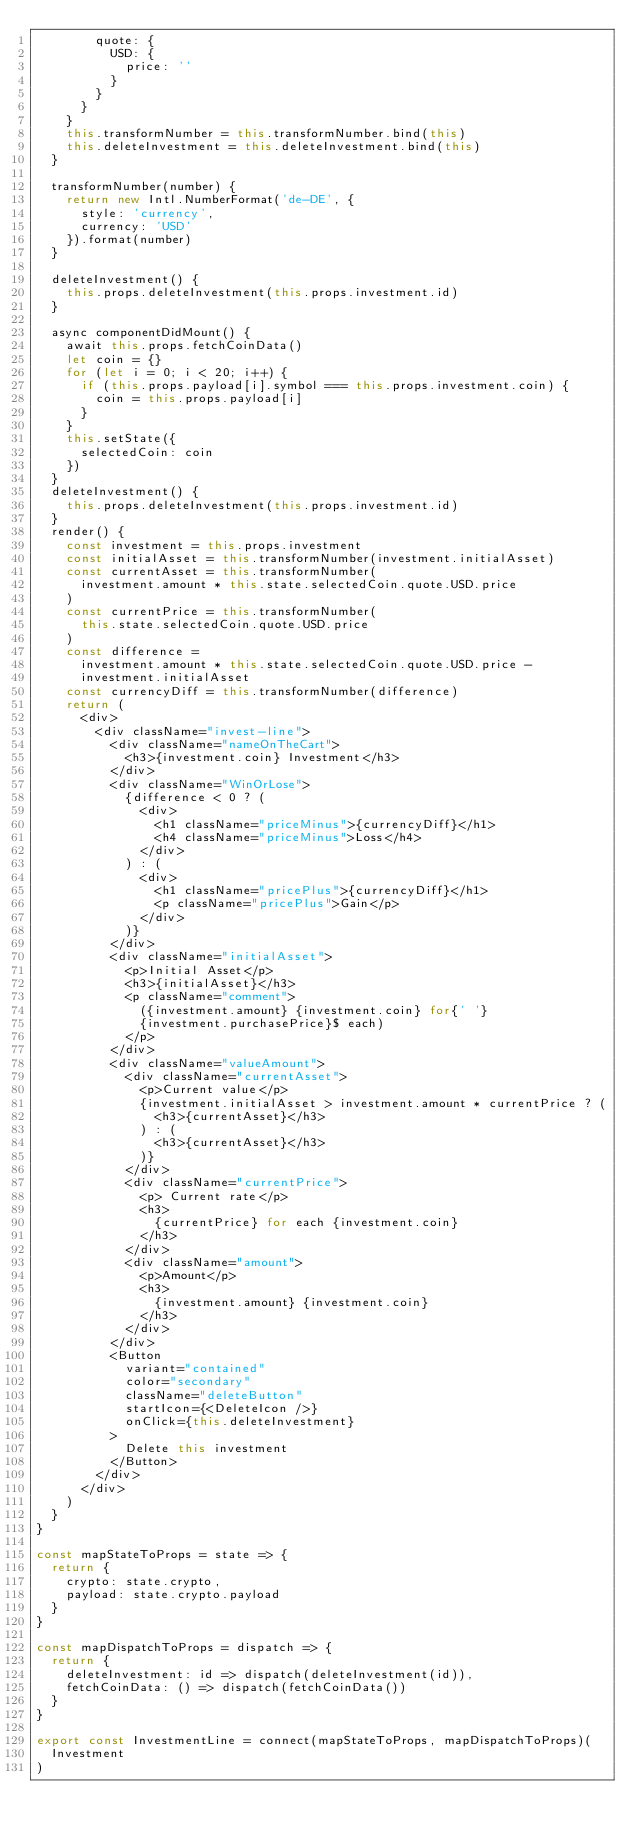Convert code to text. <code><loc_0><loc_0><loc_500><loc_500><_JavaScript_>        quote: {
          USD: {
            price: ''
          }
        }
      }
    }
    this.transformNumber = this.transformNumber.bind(this)
    this.deleteInvestment = this.deleteInvestment.bind(this)
  }

  transformNumber(number) {
    return new Intl.NumberFormat('de-DE', {
      style: 'currency',
      currency: 'USD'
    }).format(number)
  }

  deleteInvestment() {
    this.props.deleteInvestment(this.props.investment.id)
  }

  async componentDidMount() {
    await this.props.fetchCoinData()
    let coin = {}
    for (let i = 0; i < 20; i++) {
      if (this.props.payload[i].symbol === this.props.investment.coin) {
        coin = this.props.payload[i]
      }
    }
    this.setState({
      selectedCoin: coin
    })
  }
  deleteInvestment() {
    this.props.deleteInvestment(this.props.investment.id)
  }
  render() {
    const investment = this.props.investment
    const initialAsset = this.transformNumber(investment.initialAsset)
    const currentAsset = this.transformNumber(
      investment.amount * this.state.selectedCoin.quote.USD.price
    )
    const currentPrice = this.transformNumber(
      this.state.selectedCoin.quote.USD.price
    )
    const difference =
      investment.amount * this.state.selectedCoin.quote.USD.price -
      investment.initialAsset
    const currencyDiff = this.transformNumber(difference)
    return (
      <div>
        <div className="invest-line">
          <div className="nameOnTheCart">
            <h3>{investment.coin} Investment</h3>
          </div>
          <div className="WinOrLose">
            {difference < 0 ? (
              <div>
                <h1 className="priceMinus">{currencyDiff}</h1>
                <h4 className="priceMinus">Loss</h4>
              </div>
            ) : (
              <div>
                <h1 className="pricePlus">{currencyDiff}</h1>
                <p className="pricePlus">Gain</p>
              </div>
            )}
          </div>
          <div className="initialAsset">
            <p>Initial Asset</p>
            <h3>{initialAsset}</h3>
            <p className="comment">
              ({investment.amount} {investment.coin} for{' '}
              {investment.purchasePrice}$ each)
            </p>
          </div>
          <div className="valueAmount">
            <div className="currentAsset">
              <p>Current value</p>
              {investment.initialAsset > investment.amount * currentPrice ? (
                <h3>{currentAsset}</h3>
              ) : (
                <h3>{currentAsset}</h3>
              )}
            </div>
            <div className="currentPrice">
              <p> Current rate</p>
              <h3>
                {currentPrice} for each {investment.coin}
              </h3>
            </div>
            <div className="amount">
              <p>Amount</p>
              <h3>
                {investment.amount} {investment.coin}
              </h3>
            </div>
          </div>
          <Button
            variant="contained"
            color="secondary"
            className="deleteButton"
            startIcon={<DeleteIcon />}
            onClick={this.deleteInvestment}
          >
            Delete this investment
          </Button>
        </div>
      </div>
    )
  }
}

const mapStateToProps = state => {
  return {
    crypto: state.crypto,
    payload: state.crypto.payload
  }
}

const mapDispatchToProps = dispatch => {
  return {
    deleteInvestment: id => dispatch(deleteInvestment(id)),
    fetchCoinData: () => dispatch(fetchCoinData())
  }
}

export const InvestmentLine = connect(mapStateToProps, mapDispatchToProps)(
  Investment
)
</code> 